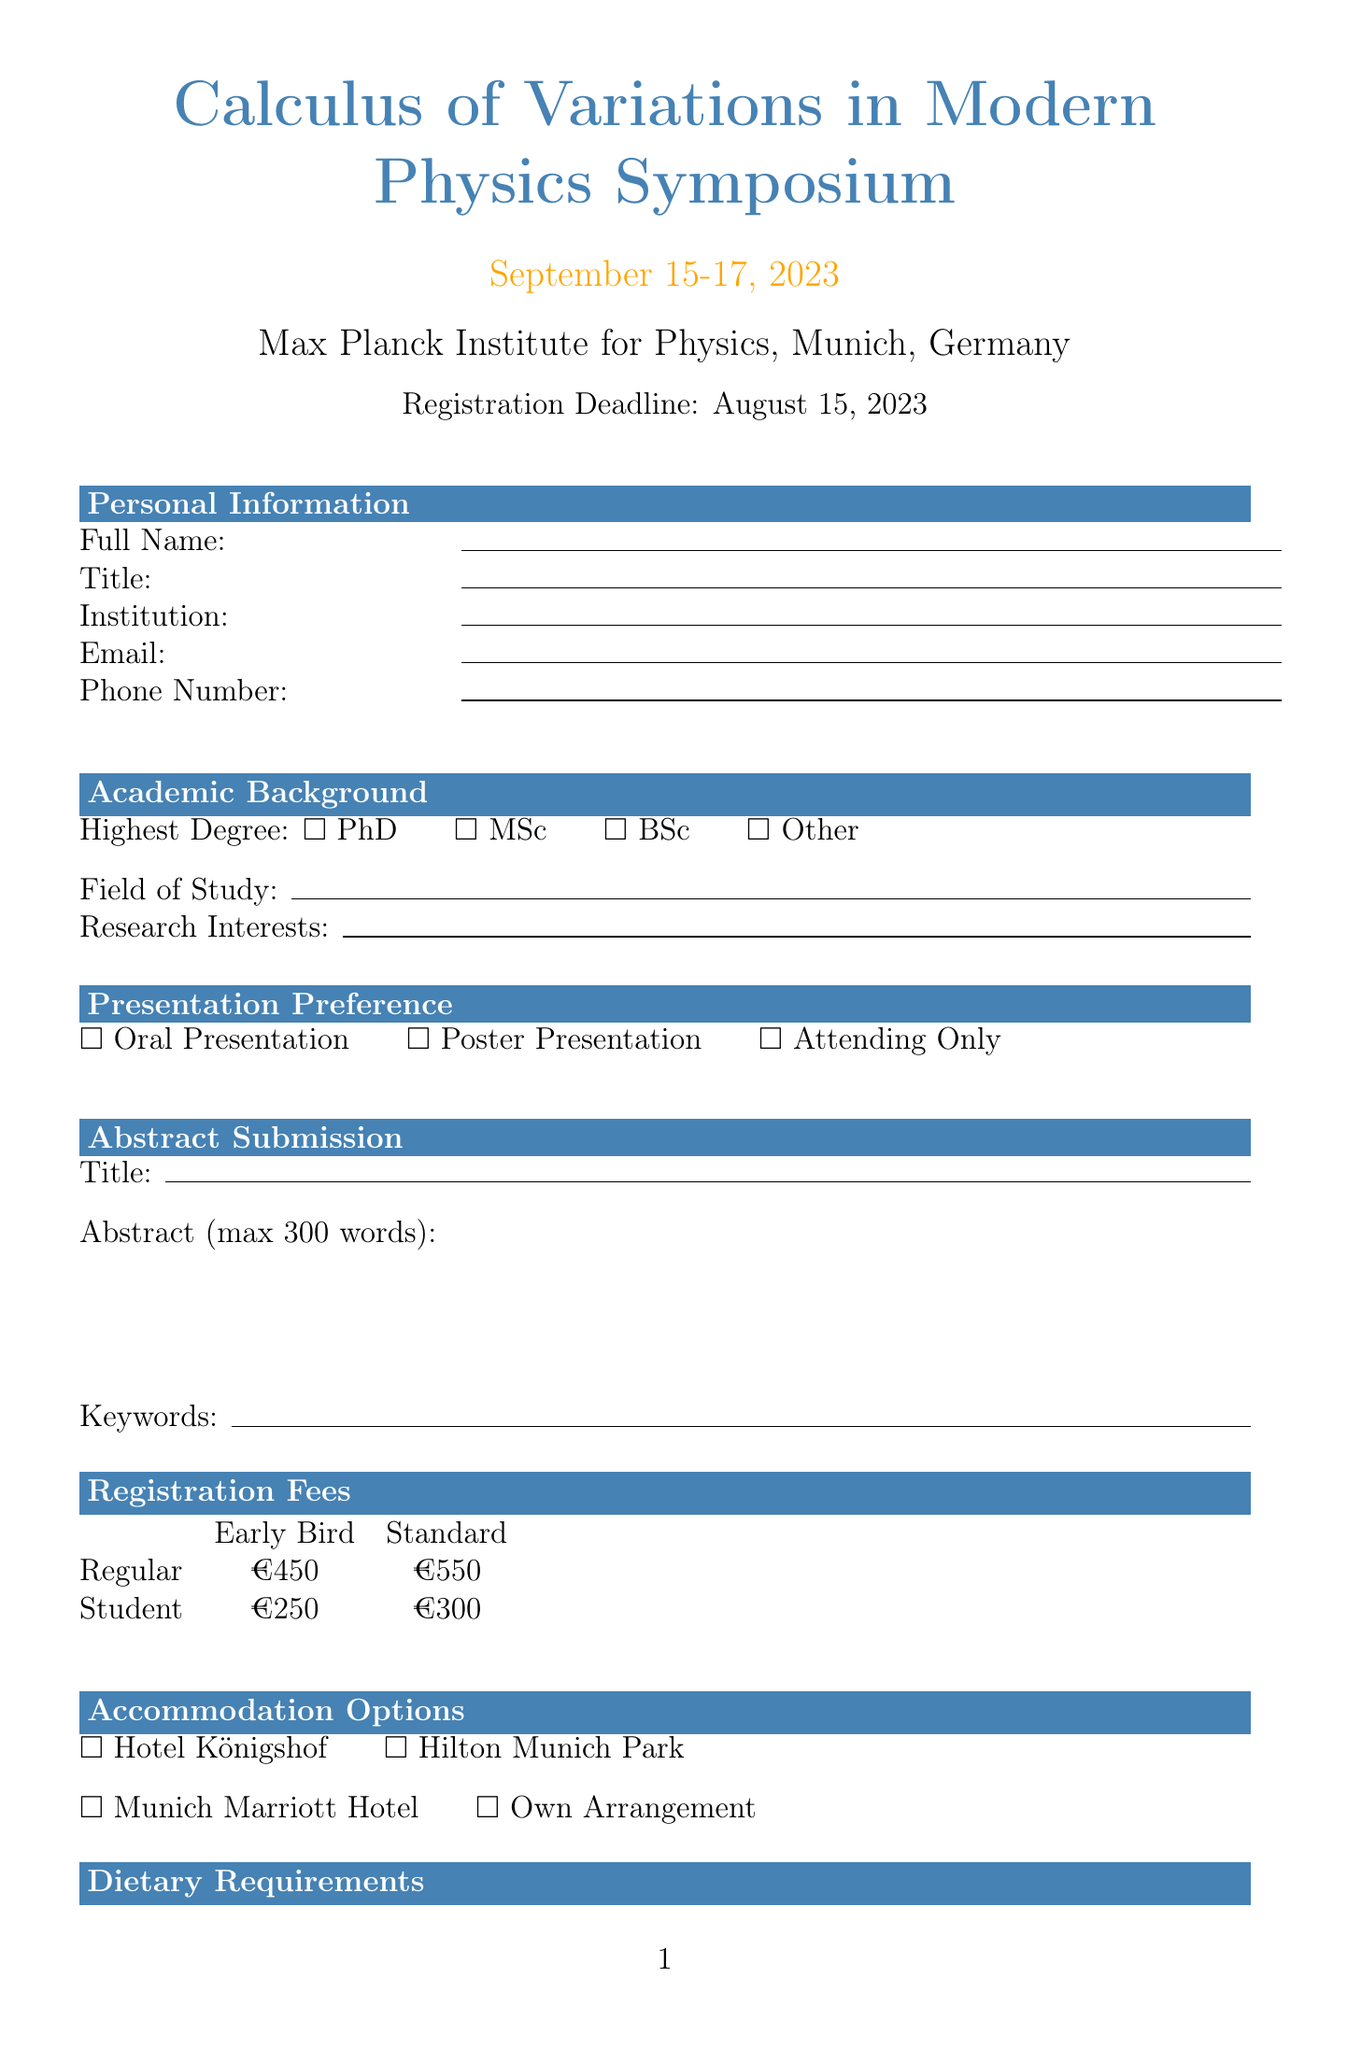what is the date of the symposium? The date of the symposium is mentioned clearly in the document as September 15-17, 2023.
Answer: September 15-17, 2023 where is the venue located? The venue for the symposium is specified in the document as the Max Planck Institute for Physics, Munich, Germany.
Answer: Max Planck Institute for Physics, Munich, Germany what is the registration deadline? The registration deadline is stated in the document as August 15, 2023.
Answer: August 15, 2023 what is the early bird registration fee for regular participants? The early bird registration fee for regular participants is listed as €450 in the document.
Answer: €450 which keynote speaker is from MIT? The document mentions that Prof. Frank Wilczek is the keynote speaker from MIT.
Answer: Prof. Frank Wilczek what options are available for workshops? The document provides options for workshops including "Introduction to Functional Analysis in QFT", "Numerical Methods in Variational Quantum Mechanics", and "Symmetries and Conservation Laws in Variational Principles".
Answer: Introduction to Functional Analysis in QFT, Numerical Methods in Variational Quantum Mechanics, Symmetries and Conservation Laws in Variational Principles is there an option for attendees to chair a session? The document asks if attendees are willing to chair a session, indicating the option is present.
Answer: Yes what is the policy on cancellation refunds? The document specifies the cancellation policy, stating full refund before August 1, 2023, 50% refund before September 1, 2023, and no refund after September 1, 2023.
Answer: Full refund before August 1, 2023 what is the intent for conference proceedings? The document inquires whether attendees intend to publish in conference proceedings, offering a yes or no option.
Answer: Yes or No 